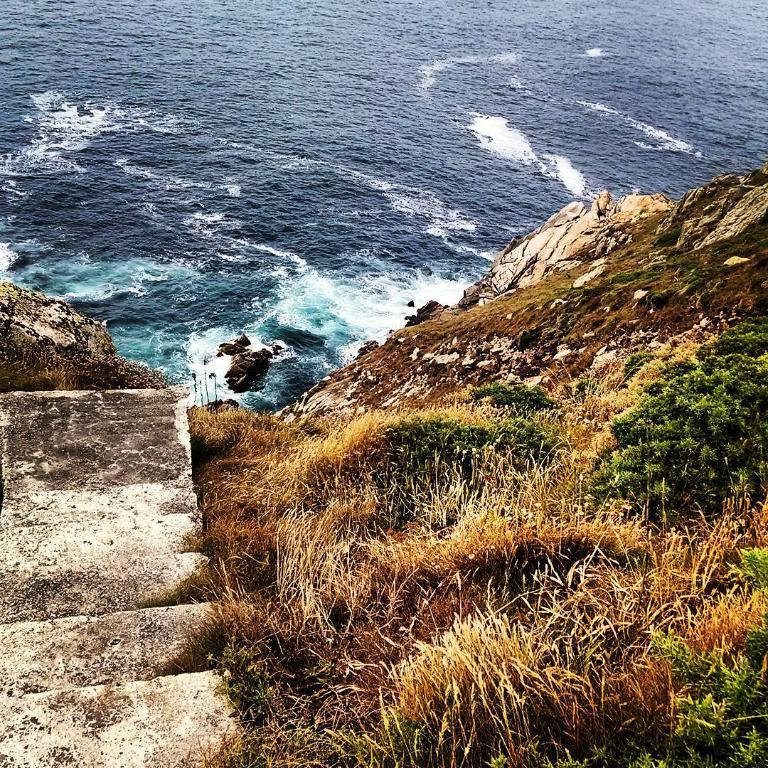What type of terrain is visible at the bottom of the image? There is dry grass and rocks at the bottom of the image. What type of surface is present in the image? There is a concrete surface in the image. What can be seen in the background of the image? There is water visible in the background of the image. Where is the bomb located in the image? There is no bomb present in the image. What type of vase can be seen in the image? There is no vase present in the image. 